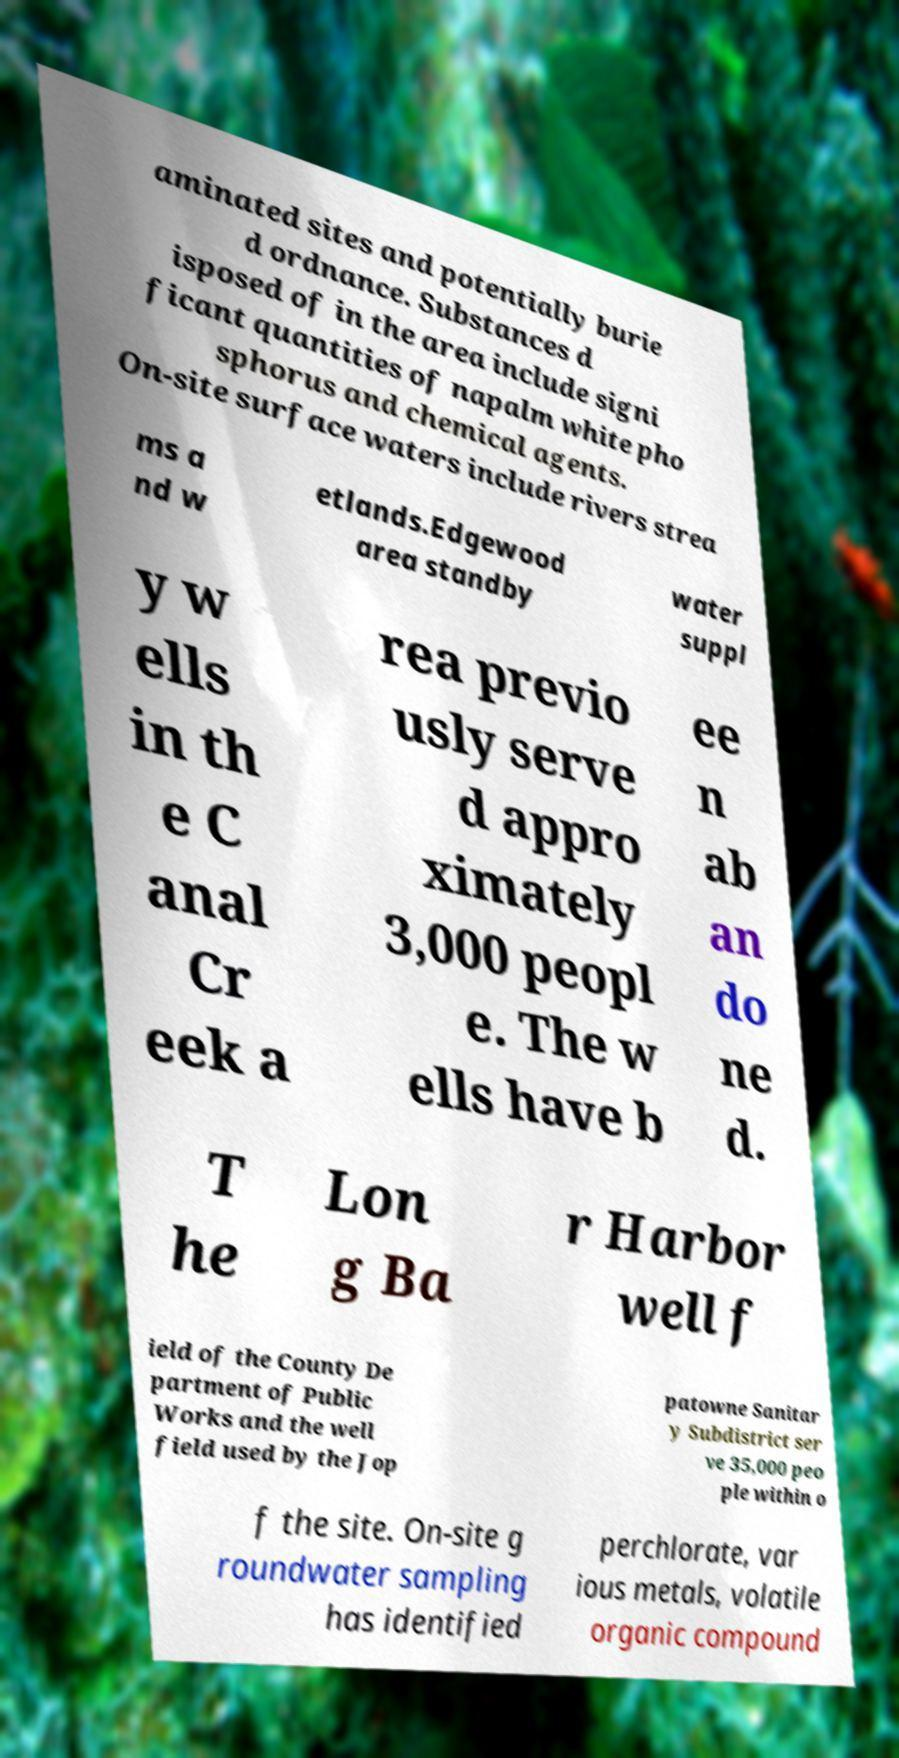There's text embedded in this image that I need extracted. Can you transcribe it verbatim? aminated sites and potentially burie d ordnance. Substances d isposed of in the area include signi ficant quantities of napalm white pho sphorus and chemical agents. On-site surface waters include rivers strea ms a nd w etlands.Edgewood area standby water suppl y w ells in th e C anal Cr eek a rea previo usly serve d appro ximately 3,000 peopl e. The w ells have b ee n ab an do ne d. T he Lon g Ba r Harbor well f ield of the County De partment of Public Works and the well field used by the Jop patowne Sanitar y Subdistrict ser ve 35,000 peo ple within o f the site. On-site g roundwater sampling has identified perchlorate, var ious metals, volatile organic compound 